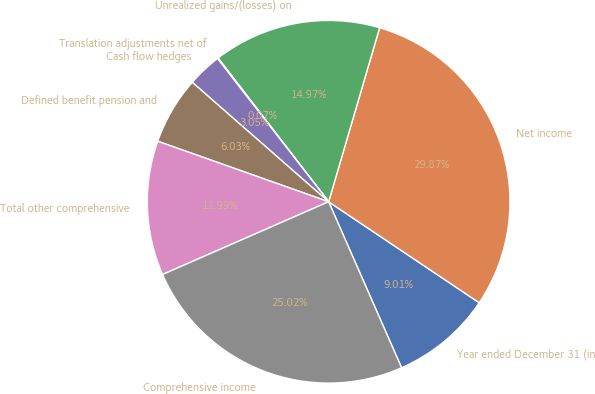Convert chart to OTSL. <chart><loc_0><loc_0><loc_500><loc_500><pie_chart><fcel>Year ended December 31 (in<fcel>Net income<fcel>Unrealized gains/(losses) on<fcel>Translation adjustments net of<fcel>Cash flow hedges<fcel>Defined benefit pension and<fcel>Total other comprehensive<fcel>Comprehensive income<nl><fcel>9.01%<fcel>29.87%<fcel>14.97%<fcel>0.07%<fcel>3.05%<fcel>6.03%<fcel>11.99%<fcel>25.02%<nl></chart> 